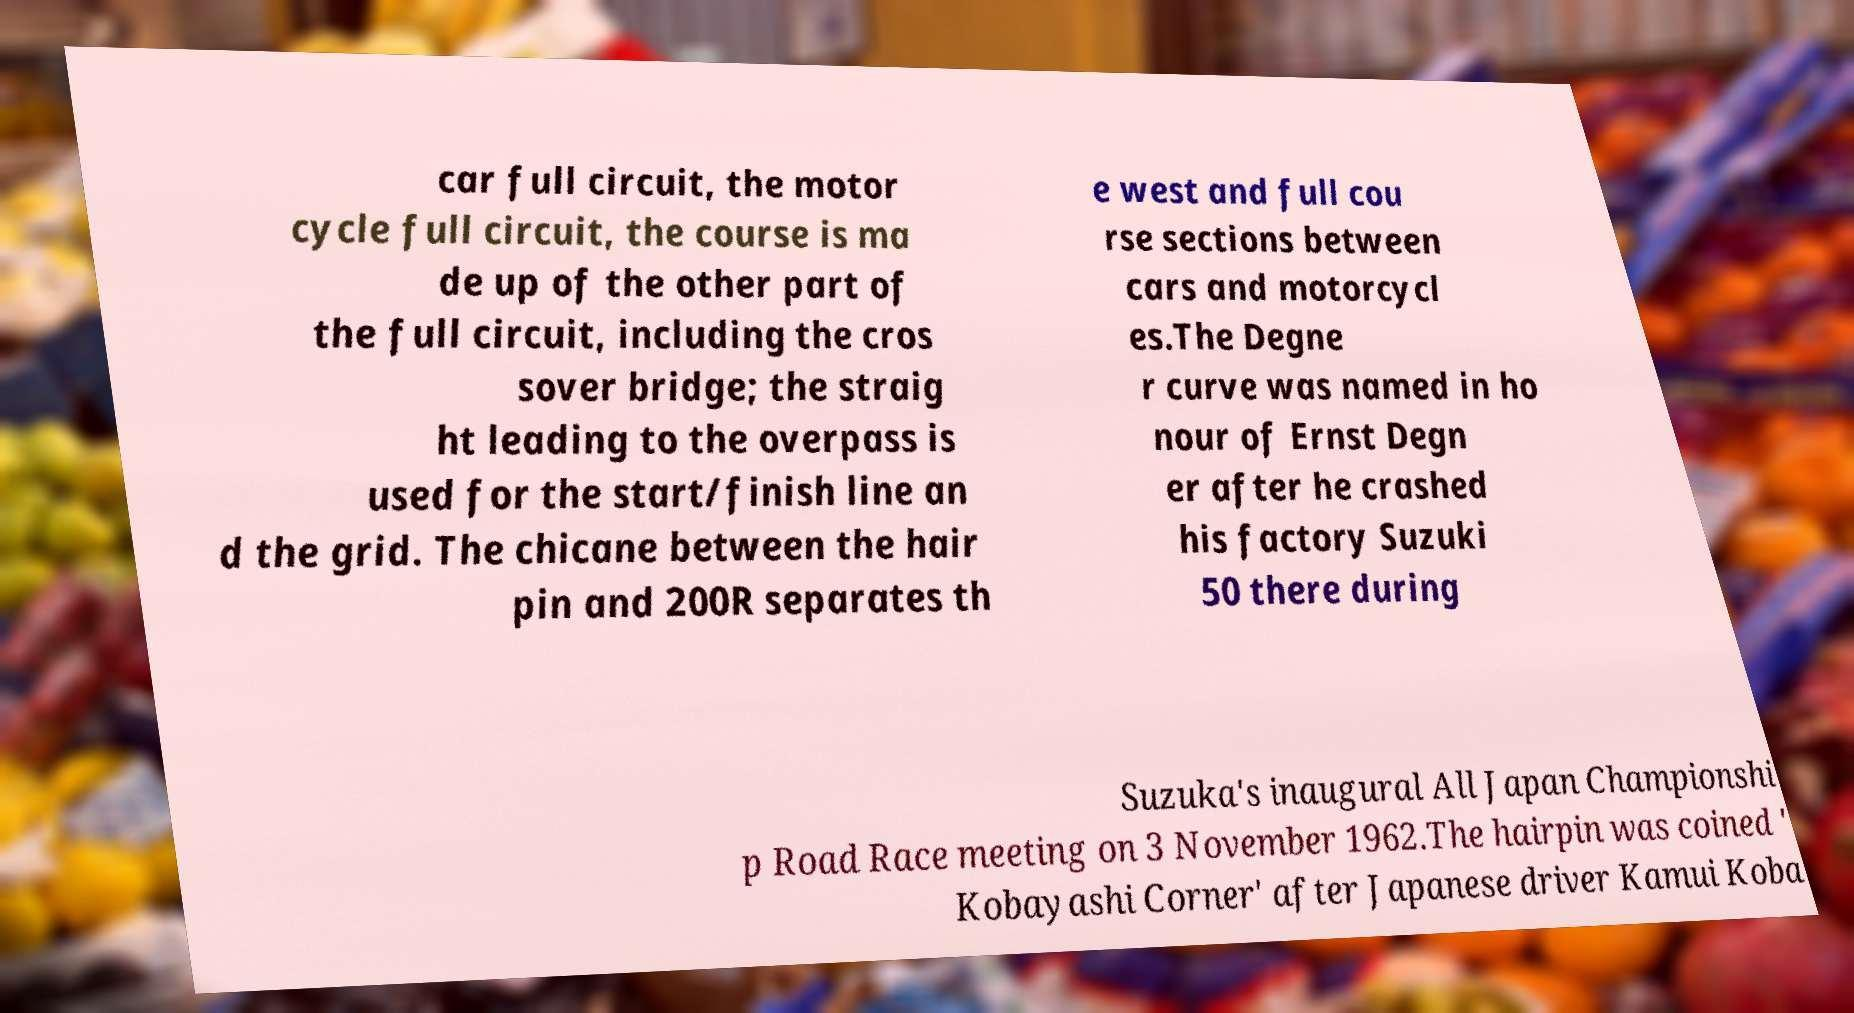Could you extract and type out the text from this image? car full circuit, the motor cycle full circuit, the course is ma de up of the other part of the full circuit, including the cros sover bridge; the straig ht leading to the overpass is used for the start/finish line an d the grid. The chicane between the hair pin and 200R separates th e west and full cou rse sections between cars and motorcycl es.The Degne r curve was named in ho nour of Ernst Degn er after he crashed his factory Suzuki 50 there during Suzuka's inaugural All Japan Championshi p Road Race meeting on 3 November 1962.The hairpin was coined ' Kobayashi Corner' after Japanese driver Kamui Koba 